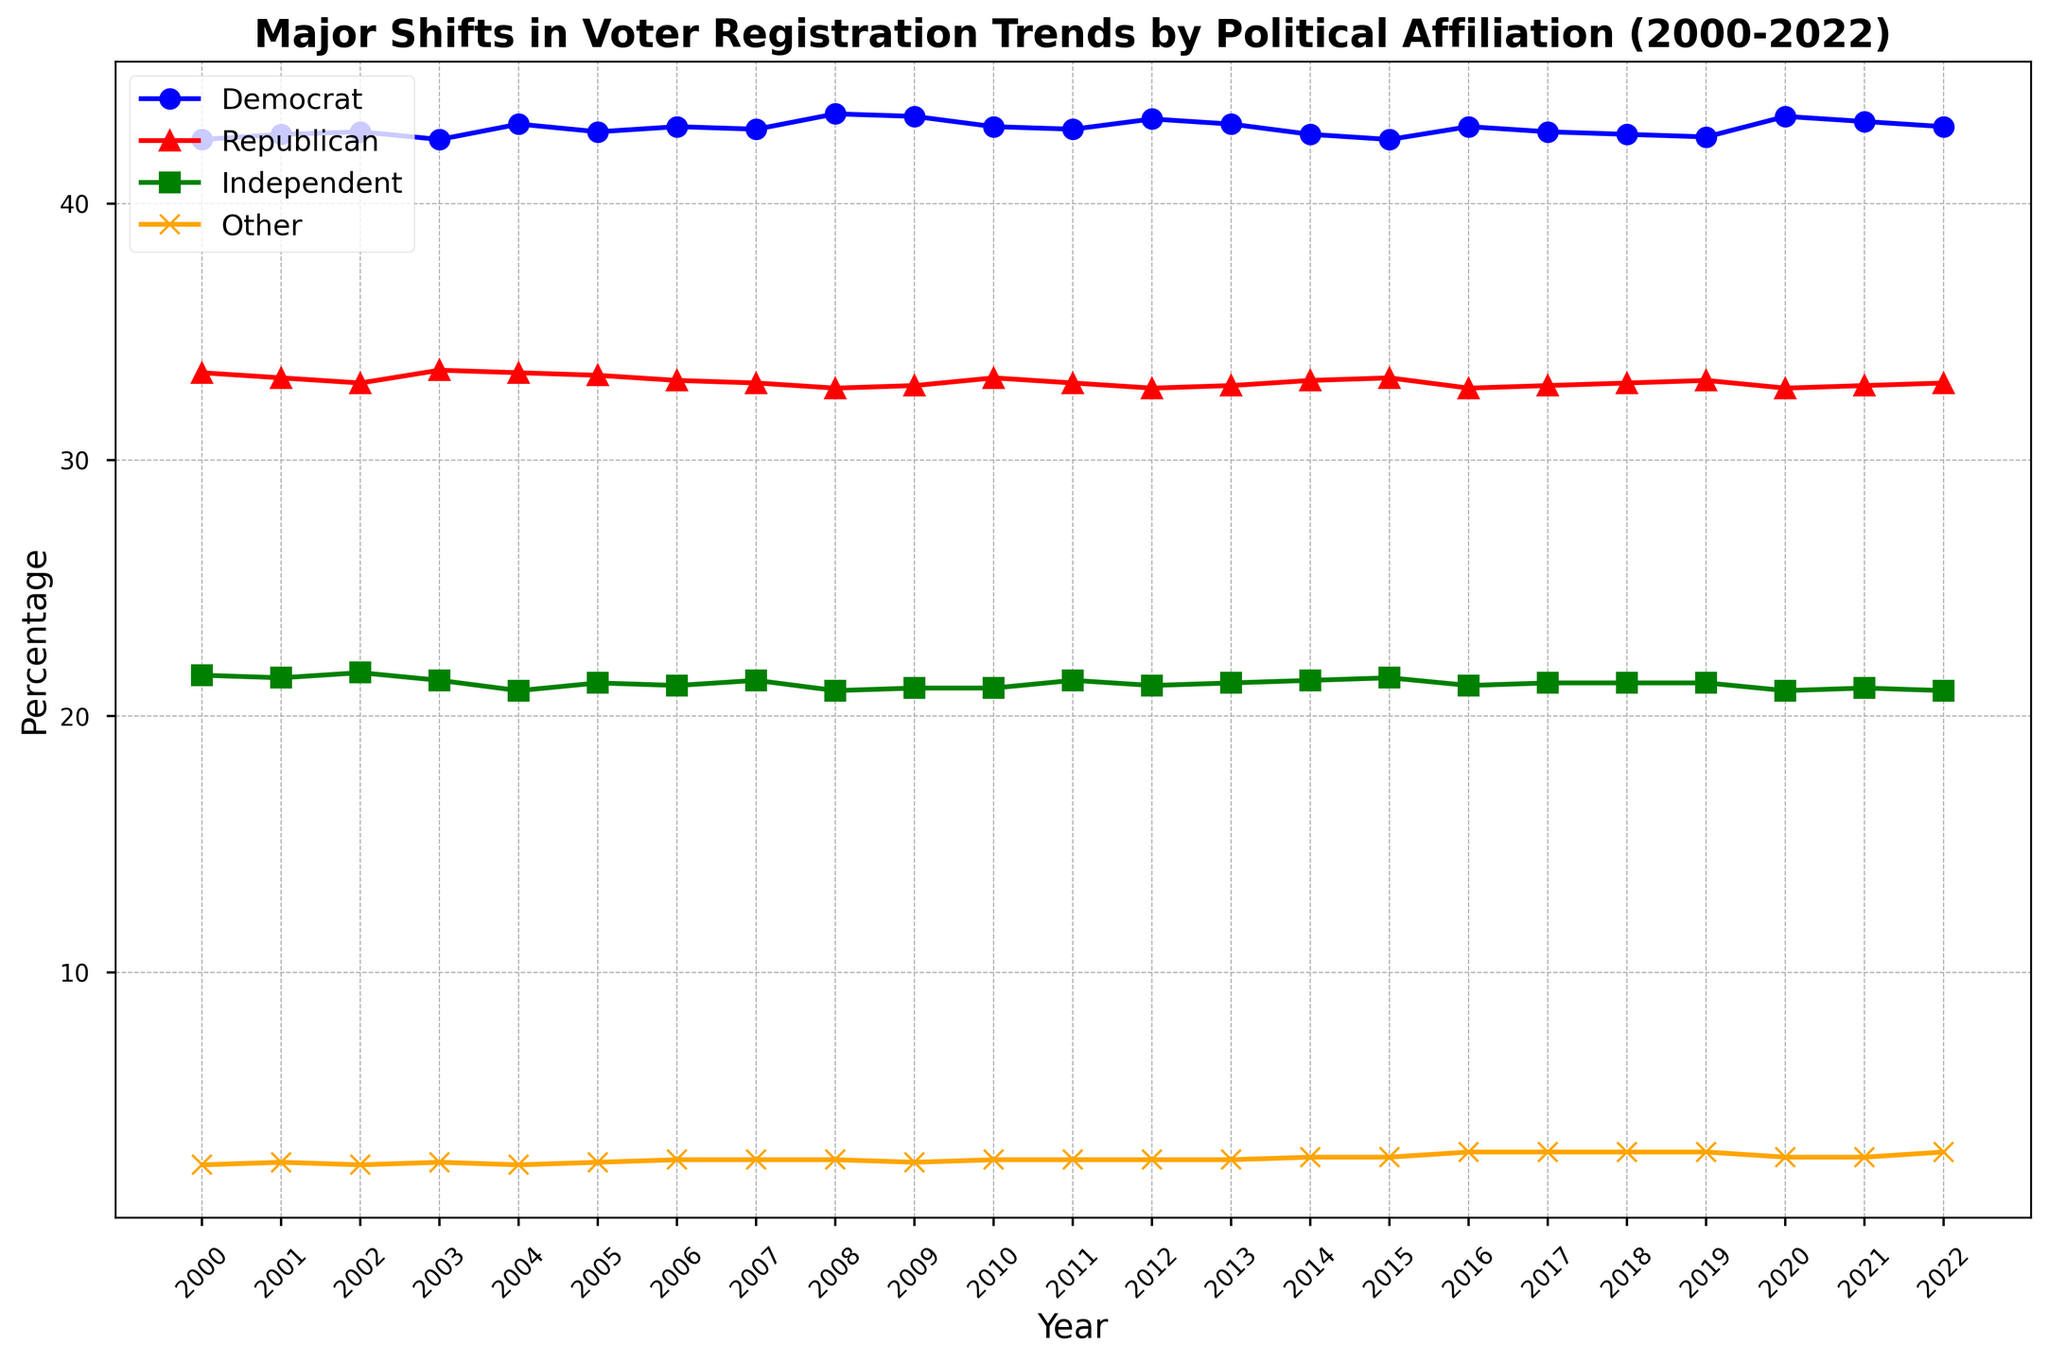What trend is observed for Democratic registrations from 2000 to 2022? The Democratic registrations show fluctuations between approximately 42.5% and 43.5% over the years, with an overall slight increasing trend towards 43.0% in 2022.
Answer: Slight increasing What is the difference in the percentage of independent voters between 2000 and 2022? In 2000, the percentage of independent voters was 21.6%, and in 2022, it was 21.0%. The difference is 21.6% - 21.0% = 0.6%.
Answer: 0.6% In which year did both Democratic and Republican registrations reach their closest values? The closest values for Democratic (43.0%) and Republican (33.0%) registrations occurred in 2022 when the difference was smallest, giving 43.0% - 33.0% = 10%.
Answer: 2022 Which political affiliation had the least fluctuation in registration percentages over the provided years? By observing the trends, 'Independent' appears to have the least fluctuation, remaining close to 21% throughout the years.
Answer: Independent Consider the years 2016 to 2020. By how much did the 'Other' category change in this period? In 2016, the percentage for 'Other' was 3.0%, and in 2020, it was 2.8%. The change is 3.0% - 2.8% = 0.2%.
Answer: 0.2% When did the Republican registrations peak? Republican registrations were highest in 2000 at 33.4%.
Answer: 2000 Compare the average percentage of Democratic voters to Republican voters from 2000 to 2022. Which is higher, and by how much? The average percentages are calculated by summing up each yearly data and dividing by the number of years:
Democrats: (42.5 + 42.7 + ... + 43.0) / 23 ≈ 43.0%
Republicans: (33.4 + 33.2 + ... + 33.0) / 23 ≈ 33.0%
The average difference is 43.0% - 33.0% = 10.0%.
Answer: Democratic by 10.0% What's the visual distinction between Democratic and Republican trends on the plot? Democratic trends are depicted in blue lines with circle markers, while Republican trends are shown in red lines with triangle markers.
Answer: Color & Marker Shape Between 2008 and 2021, how does the trend of Independent voters compare to that of the Other category? Independent voter percentages remained fairly stable around 21%, whereas the Other category increased modestly from 2.7% to 3.0%.
Answer: Stable vs. Increase What significant trend shift can be observed for the 'Other' category from 2000 to 2022? The 'Other' category shows a gradual increase from 2.5% in 2000 to 3.0% in 2022.
Answer: Gradual increase 